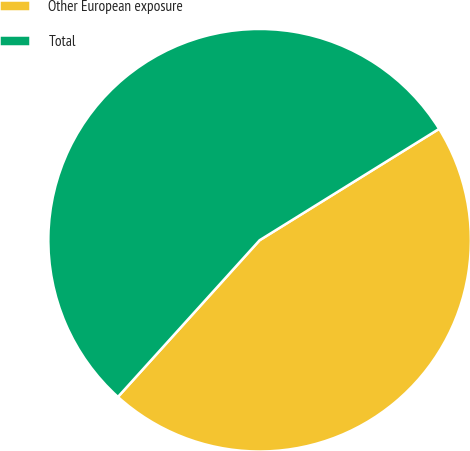<chart> <loc_0><loc_0><loc_500><loc_500><pie_chart><fcel>Other European exposure<fcel>Total<nl><fcel>45.54%<fcel>54.46%<nl></chart> 